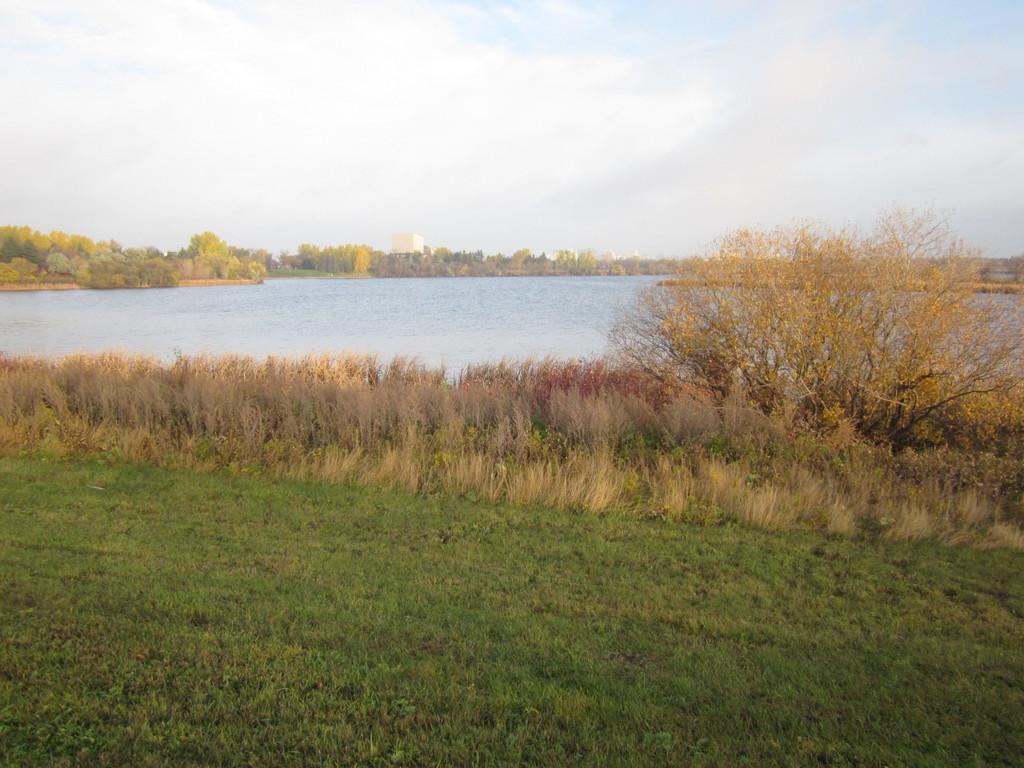Please provide a concise description of this image. In the picture I can see a greenery ground and there is a tree in the right corner and there is water in front of it and there are trees in the background. 